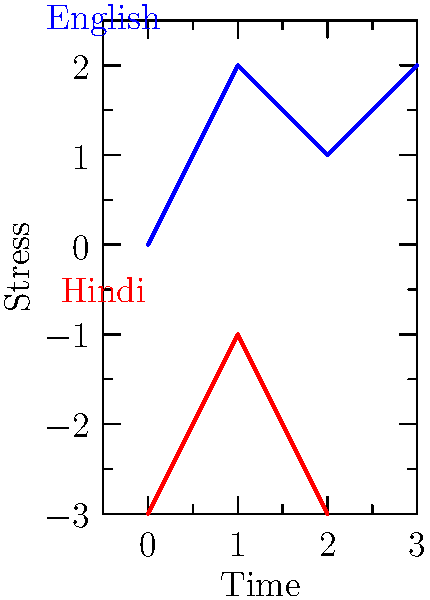Analyze the waveform graphs representing the stress patterns of the English word "banana" and its Hindi equivalent "केला" (kela). What key difference can you observe in the stress placement between these two languages? To analyze the stress patterns in the given waveform graphs:

1. English word "banana":
   - The graph shows three peaks, with the second peak being the highest.
   - This indicates a stress pattern of: unstressed-stressed-unstressed (baNAna).
   - The stress is on the second syllable, which is typical for many English words.

2. Hindi word "केला" (kela):
   - The graph shows two peaks, with the first peak being higher.
   - This indicates a stress pattern of: stressed-unstressed (KEla).
   - The stress is on the first syllable, which is common in Hindi.

3. Key difference:
   - English shows a tendency for stress on non-initial syllables (second syllable in this case).
   - Hindi demonstrates a preference for stress on the initial syllable.

This difference reflects the general stress patterns in both languages:
- English often has variable stress placement, frequently on non-initial syllables.
- Hindi typically has fixed stress on the first syllable of a word.

These patterns are crucial in understanding the prosody and rhythm of each language, which is essential for natural-sounding speech and accurate pronunciation.
Answer: English stresses a non-initial syllable (second), while Hindi stresses the initial syllable. 